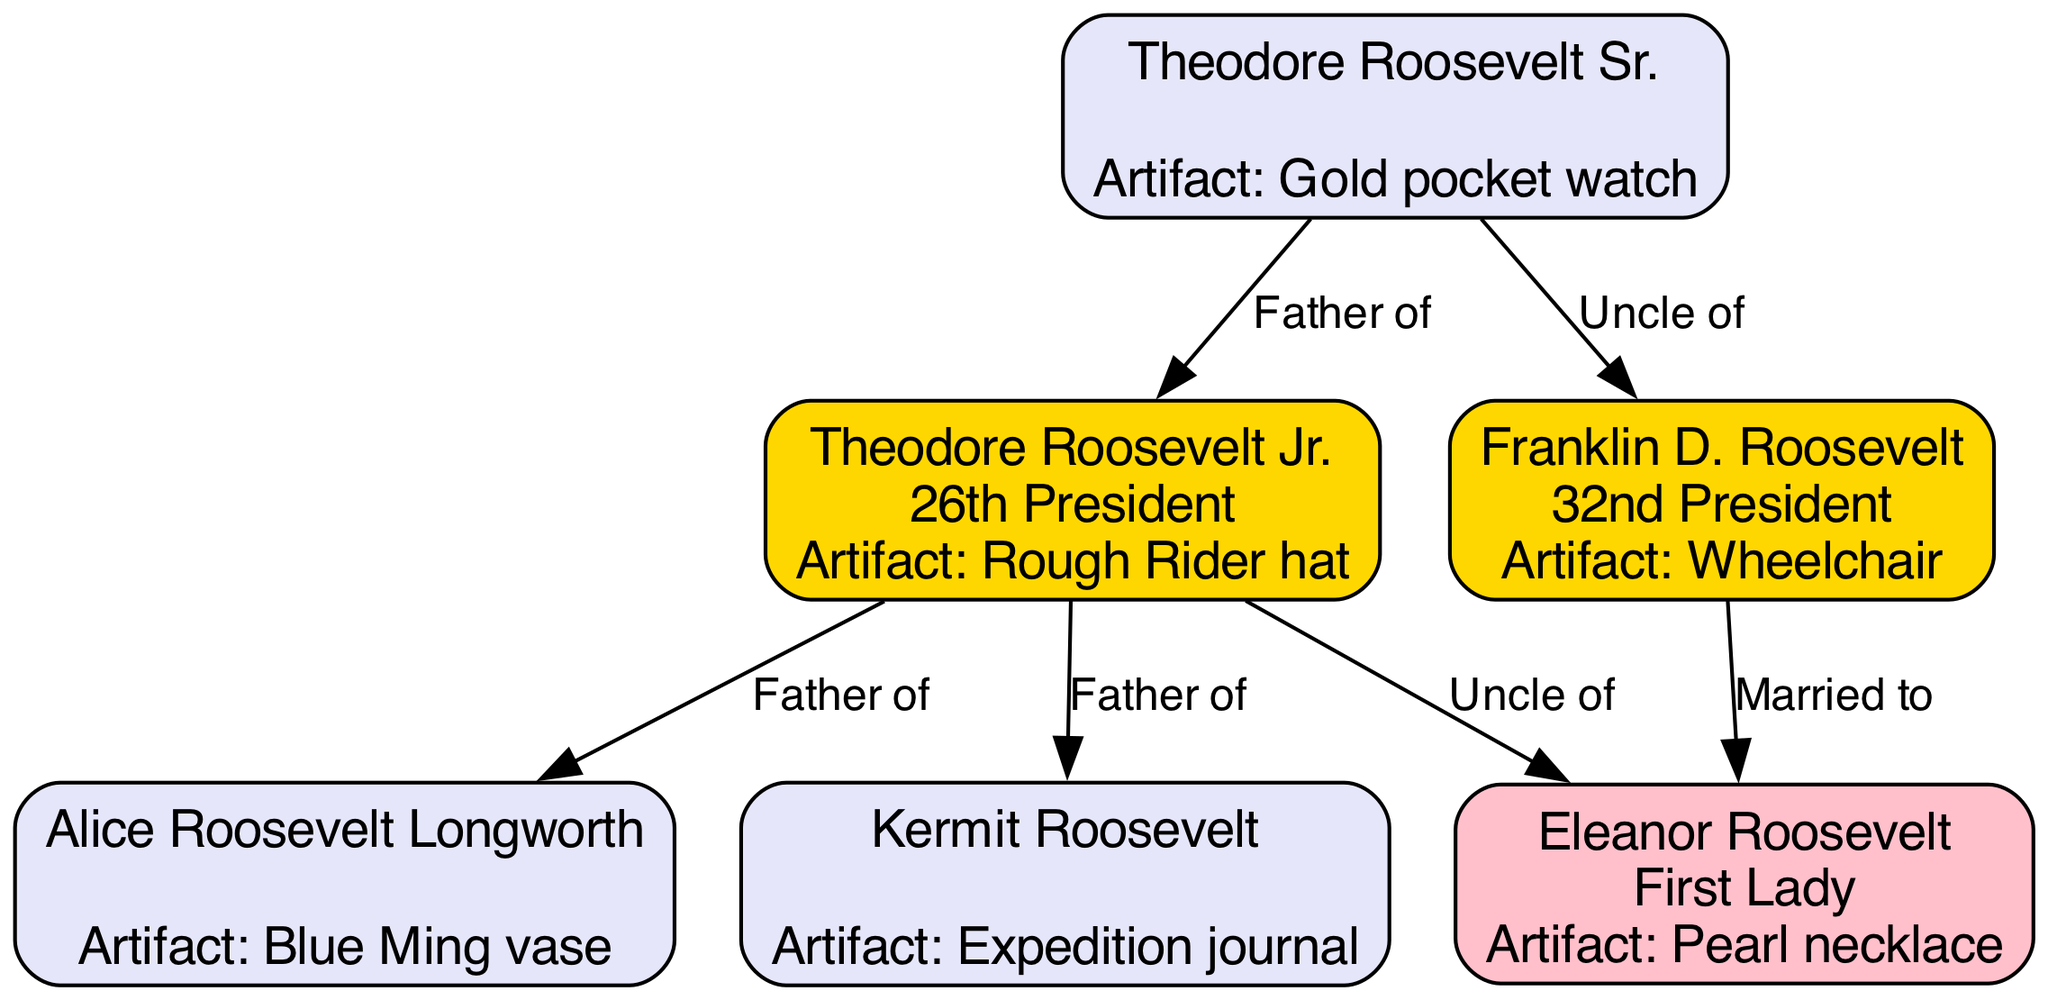What is the artifact associated with Franklin D. Roosevelt? The diagram indicates that Franklin D. Roosevelt is associated with a "Wheelchair" as his notable artifact.
Answer: Wheelchair Who is the father of Alice Roosevelt Longworth? The diagram shows that Theodore Roosevelt Jr. has a direct relationship labeled "Father of" with Alice Roosevelt Longworth.
Answer: Theodore Roosevelt Jr How many nodes are there in the diagram? By counting all the unique entities listed in the nodes section of the diagram, there are 6 different nodes.
Answer: 6 What color represents the First Lady in this diagram? The diagram uses pink (#FFC0CB) to represent the role of the First Lady.
Answer: Pink Who is the uncle of Franklin D. Roosevelt? The diagram indicates that Theodore Roosevelt Sr. is the uncle of Franklin D. Roosevelt.
Answer: Theodore Roosevelt Sr What is the relationship label between Theodore Roosevelt Jr. and Kermit Roosevelt? The diagram specifies the relationship with the label "Father of" between these two nodes.
Answer: Father of Which artifact is associated with Theodore Roosevelt Sr.? According to the diagram, Theodore Roosevelt Sr. is associated with the "Gold pocket watch."
Answer: Gold pocket watch How many edges are connecting the nodes in the diagram? By thoroughly reviewing the edges provided in the diagram, it can be concluded that there are 6 connections in total.
Answer: 6 What is the relationship between Franklin D. Roosevelt and Eleanor Roosevelt? The diagram clearly indicates that Franklin D. Roosevelt is "Married to" Eleanor Roosevelt.
Answer: Married to 